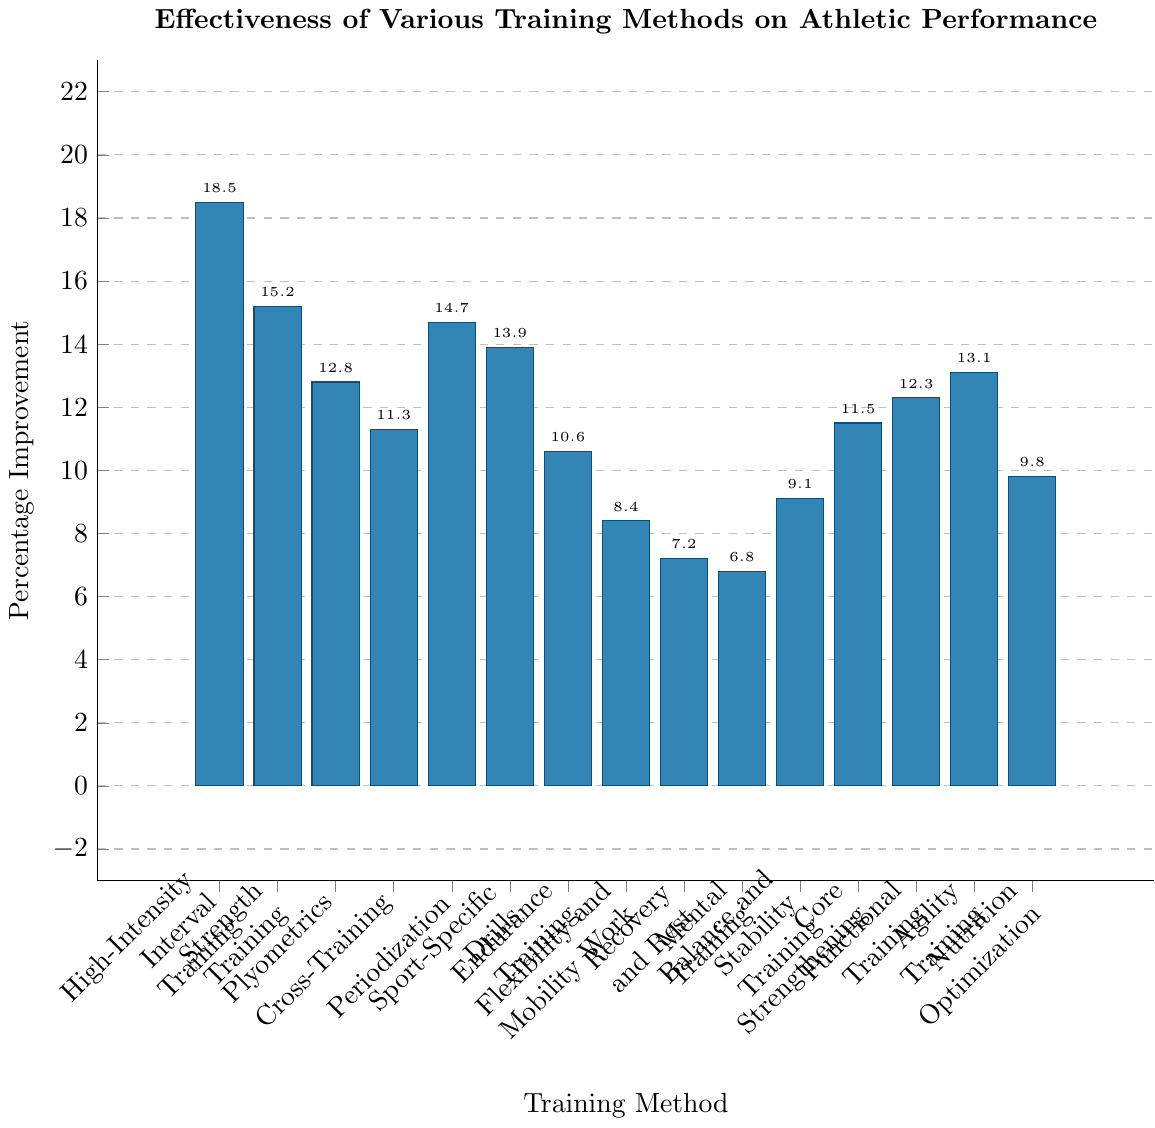Which training method has the highest percentage improvement? By examining the height of the bars, we can see which one reaches the highest point. High-Intensity Interval Training has the bar that reaches the highest, indicating it has the highest percentage improvement.
Answer: High-Intensity Interval Training What is the total percentage improvement for Strength Training and Plyometrics combined? To find the total, add the percentage improvements of both methods. Strength Training is 15.2% and Plyometrics is 12.8%. Thus, 15.2 + 12.8 = 28%.
Answer: 28% How does the percentage improvement of Core Strengthening compare to Endurance Training? By comparing the heights of the bars, Core Strengthening (11.5%) is higher than Endurance Training (10.6%). Therefore, Core Strengthening has a greater percentage improvement.
Answer: Core Strengthening is higher Which training method has the lowest percentage improvement? By examining the height of the bars, we can see which one is the shortest. Mental Training has the shortest bar, indicating it has the lowest percentage improvement.
Answer: Mental Training How much greater is the percentage improvement of Periodization compared to Recovery and Rest? To find the difference, subtract the percentage improvement of Recovery and Rest from that of Periodization. Periodization is 14.7% and Recovery and Rest is 7.2%. Thus, 14.7 - 7.2 = 7.5%.
Answer: 7.5% What is the average percentage improvement of Agility Training, Core Strengthening, and Balance and Stability Training? Add the percentage improvements of the three training methods and divide by 3 to find the average. Agility Training is 13.1%, Core Strengthening is 11.5%, and Balance and Stability Training is 9.1%. Thus, (13.1 + 11.5 + 9.1) / 3 ≈ 11.23%.
Answer: 11.23% Which training method has a percentage improvement closest to 10%? By examining the heights of the bars, it is evident that there are a few training methods around 10%, but Endurance Training at 10.6% is the closest to 10%.
Answer: Endurance Training Are there any training methods with an identical percentage improvement? By comparing the heights of all the bars, we can see if any two bars are of equal height. All bars have unique heights, indicating no training methods have identical percentage improvements.
Answer: No How does the cumulative percentage improvement of Mental Training and Flexibility and Mobility Work compare to that of High-Intensity Interval Training alone? First, add the improvements of Mental Training and Flexibility and Mobility Work: 6.8% + 8.4% = 15.2%. Compare this sum to High-Intensity Interval Training's improvement of 18.5%. 18.5% is greater than 15.2%.
Answer: High-Intensity Interval Training is greater What is the percentage improvement difference between the training method with the highest improvement and the one with the lowest? Subtract the lowest percentage improvement from the highest. The highest is High-Intensity Interval Training at 18.5% and the lowest is Mental Training at 6.8%. Thus, 18.5 - 6.8 = 11.7%.
Answer: 11.7% 